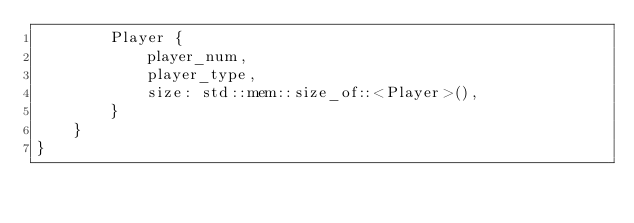<code> <loc_0><loc_0><loc_500><loc_500><_Rust_>        Player {
            player_num,
            player_type,
            size: std::mem::size_of::<Player>(),
        }
    }
}
</code> 